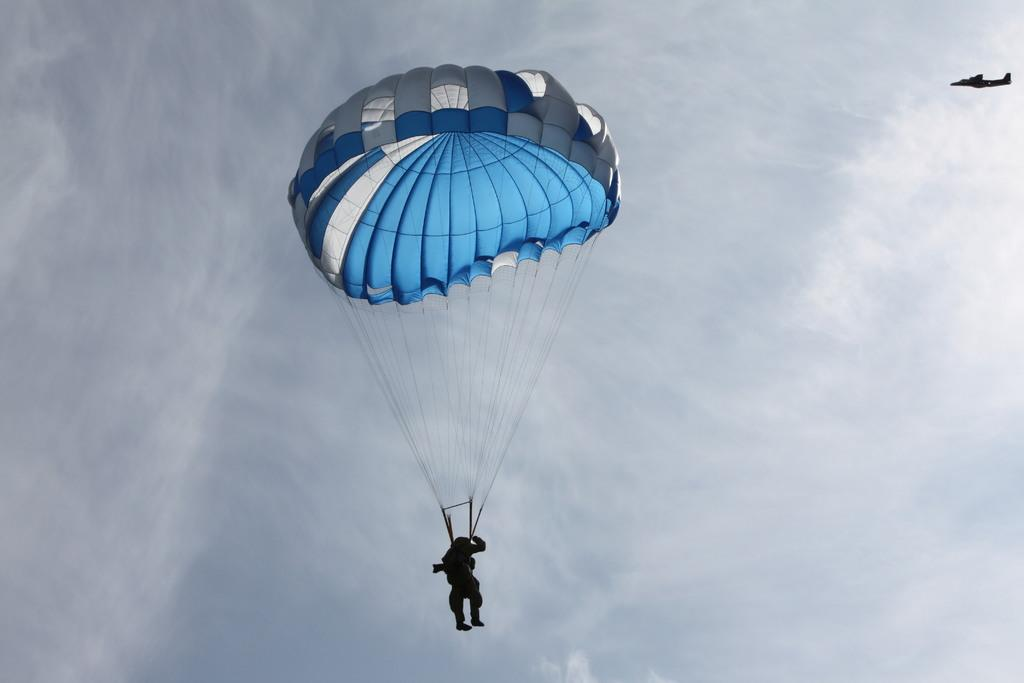What is the person in the image doing? The person in the image is in the air with a parachute. What can be seen in the image besides the person with a parachute? There is an airplane in the image. What is visible in the background of the image? The sky is visible in the background, and clouds are present in the sky. What type of shock can be seen on the person's face in the image? There is no indication of a person's face or any shock in the image, as it only shows a person with a parachute in the air. 